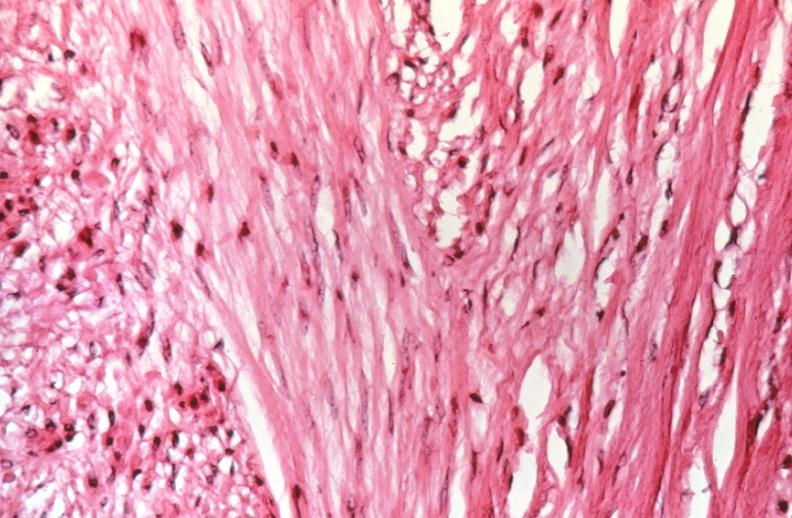does this image show uterus, leiomyomas?
Answer the question using a single word or phrase. Yes 